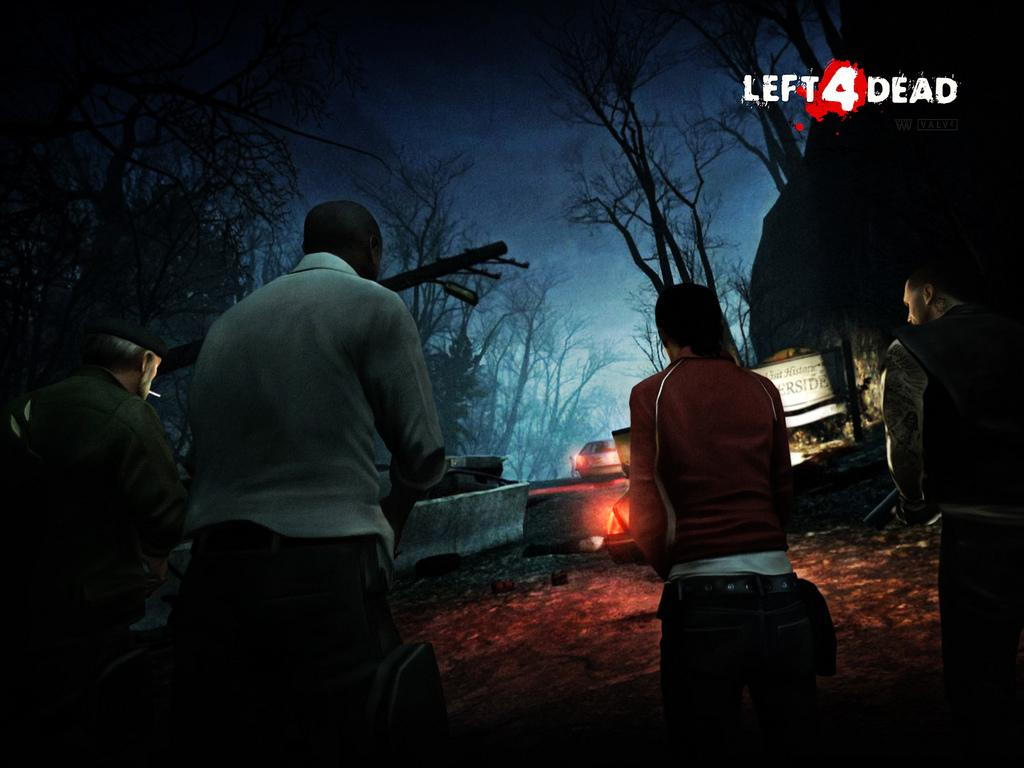How many people are in the image? There are people in the image, but the exact number is not specified. What are the people doing in the image? The people are standing in the image. What can be seen on the road in the image? There is a vehicle on the road in the image. What is present in the background of the image? There is a wall and trees in the background of the image. How would you describe the sky in the image? The sky is dark in the background of the image. What type of coal is being used to fuel the attention of the people in the image? There is no coal or attention being fueled in the image; it simply shows people standing and a vehicle on the road. 